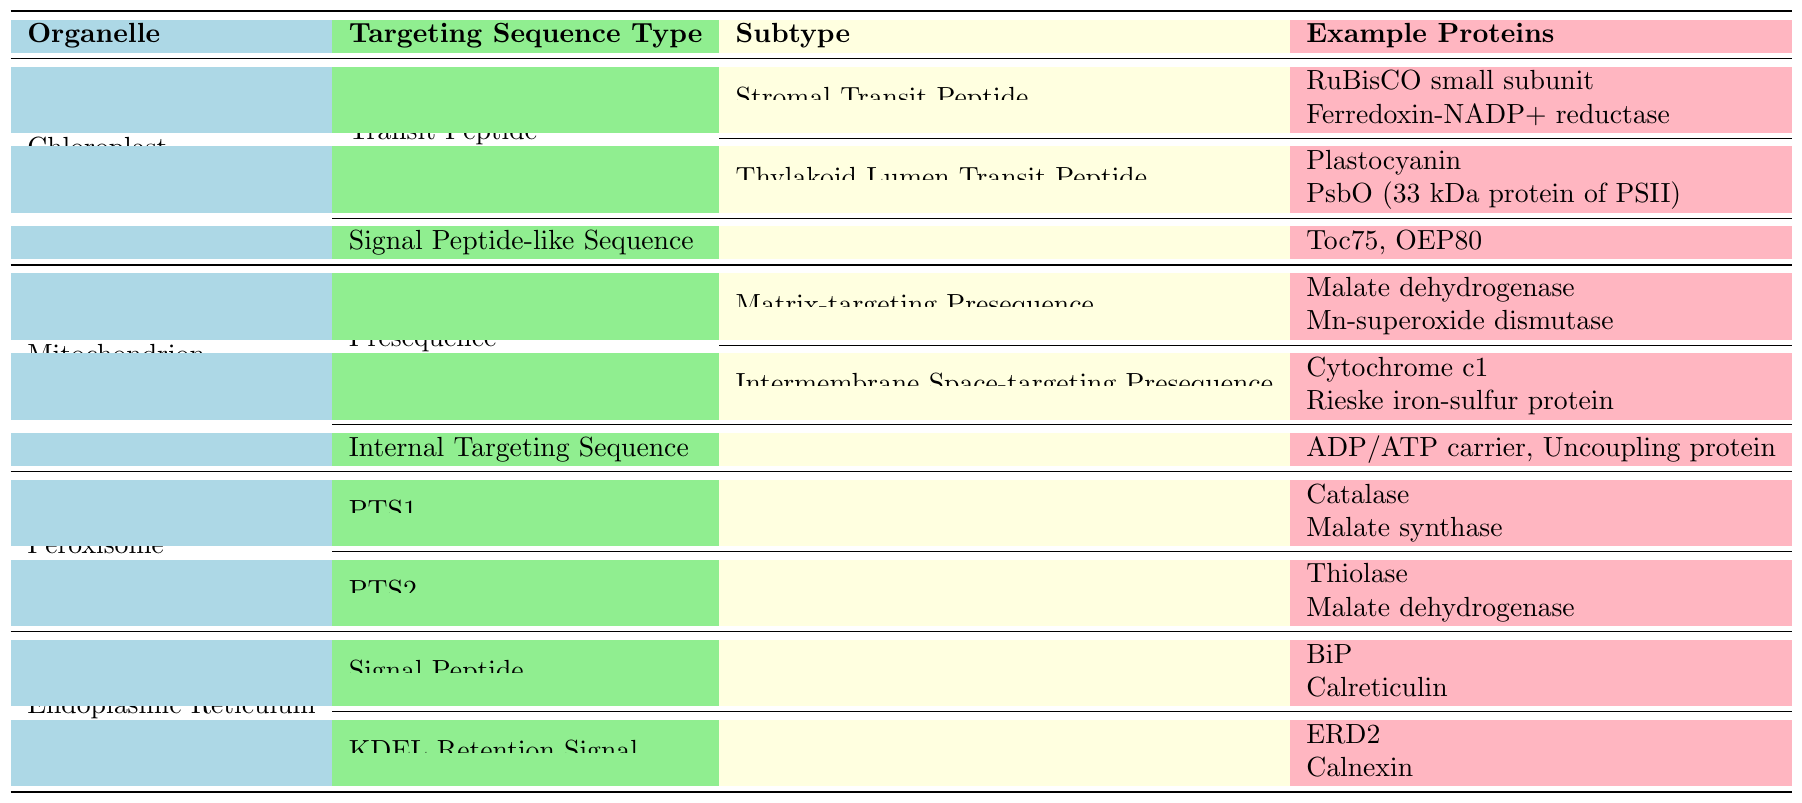What is the primary organelle that contains proteins with the "Transit Peptide" targeting sequence? The table indicates that the "Transit Peptide" targeting sequence is categorized under the "Chloroplast" organelle.
Answer: Chloroplast How many different subtypes of "Transit Peptide" are listed for the Chloroplast? According to the table, under the "Chloroplast" organelle, there are two subtypes listed for "Transit Peptide": "Stromal Transit Peptide" and "Thylakoid Lumen Transit Peptide."
Answer: 2 Which organelle has proteins targeted by "PTS1" and how many example proteins are provided for it? The table shows that the "Peroxisome" organelle has "PTS1" as a targeting sequence type. It lists three example proteins: Catalse, Malate synthase, and Isocitrate lyase.
Answer: Peroxisome; 3 Are there any organelles that have both a "Signal Peptide" and a "KDEL Retention Signal"? The table shows that the "Endoplasmic Reticulum" organelle has both "Signal Peptide" and "KDEL Retention Signal" listed as targeting sequence types. Therefore, the answer is yes.
Answer: Yes Which subtype under the "Mitochondrion" targeting sequence has the most example proteins, and how many are there? The "Presequence" targeting type under "Mitochondrion" has two subtypes: "Matrix-targeting Presequence" (3 example proteins) and "Intermembrane Space-targeting Presequence" (2 example proteins). Therefore, "Matrix-targeting Presequence" has the most example proteins, totaling 3.
Answer: Matrix-targeting Presequence; 3 If you were to compare the number of targeting sequence types between Chloroplast and Peroxisome, which has more? Chloroplast has two targeting sequence types ("Transit Peptide" and "Signal Peptide-like Sequence"), while Peroxisome has two types as well ("PTS1" and "PTS2"). Therefore, they are equal in number.
Answer: Equal What is the unique aspect of Ralph Bock's research area regarding chloroplasts based on the information provided? The unique aspect of Ralph Bock's research includes developing methods for chloroplast transformation and identifying novel chloroplast-targeting sequences, which is crucial for understanding protein import into chloroplasts.
Answer: Chloroplast transformation methods and targeting sequences Can you find any relationship between the targeting sequences of Mitochondrion and peroxisome based on their function? Both organelles have specific targeting sequences that facilitate the import of proteins; Mitochondrion has types like "Presequence" for protein import, while Peroxisome contains "PTS1" and "PTS2" to direct enzymes.
Answer: Yes, both target proteins for import Which organelle has a targeting sequence type termed "Signal Peptide-like Sequence," and what are the example proteins? The "Chloroplast" organelle has a targeting sequence type called "Signal Peptide-like Sequence," with example proteins Toc75 and OEP80.
Answer: Chloroplast; Toc75, OEP80 How many total example proteins are listed for the "Endoplasmic Reticulum"? The "Endoplasmic Reticulum" has two targeting types: "Signal Peptide" (3 example proteins) and "KDEL Retention Signal" (3 example proteins), giving a total of 6 example proteins combined.
Answer: 6 